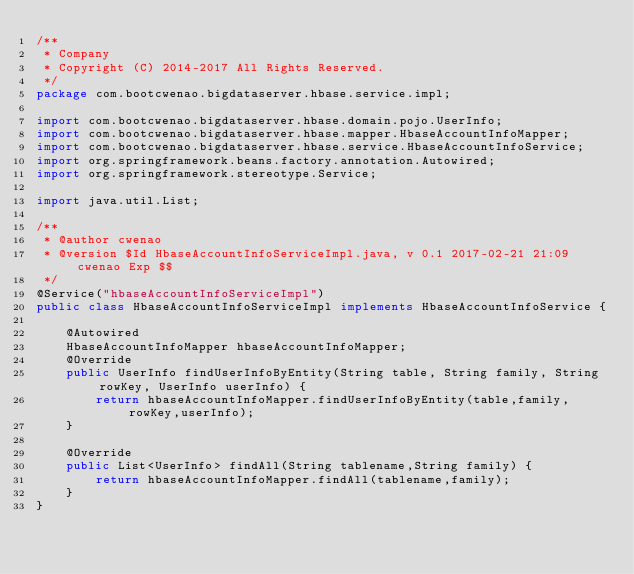<code> <loc_0><loc_0><loc_500><loc_500><_Java_>/**
 * Company
 * Copyright (C) 2014-2017 All Rights Reserved.
 */
package com.bootcwenao.bigdataserver.hbase.service.impl;

import com.bootcwenao.bigdataserver.hbase.domain.pojo.UserInfo;
import com.bootcwenao.bigdataserver.hbase.mapper.HbaseAccountInfoMapper;
import com.bootcwenao.bigdataserver.hbase.service.HbaseAccountInfoService;
import org.springframework.beans.factory.annotation.Autowired;
import org.springframework.stereotype.Service;

import java.util.List;

/**
 * @author cwenao
 * @version $Id HbaseAccountInfoServiceImpl.java, v 0.1 2017-02-21 21:09 cwenao Exp $$
 */
@Service("hbaseAccountInfoServiceImpl")
public class HbaseAccountInfoServiceImpl implements HbaseAccountInfoService {

    @Autowired
    HbaseAccountInfoMapper hbaseAccountInfoMapper;
    @Override
    public UserInfo findUserInfoByEntity(String table, String family, String rowKey, UserInfo userInfo) {
        return hbaseAccountInfoMapper.findUserInfoByEntity(table,family,rowKey,userInfo);
    }

    @Override
    public List<UserInfo> findAll(String tablename,String family) {
        return hbaseAccountInfoMapper.findAll(tablename,family);
    }
}

</code> 